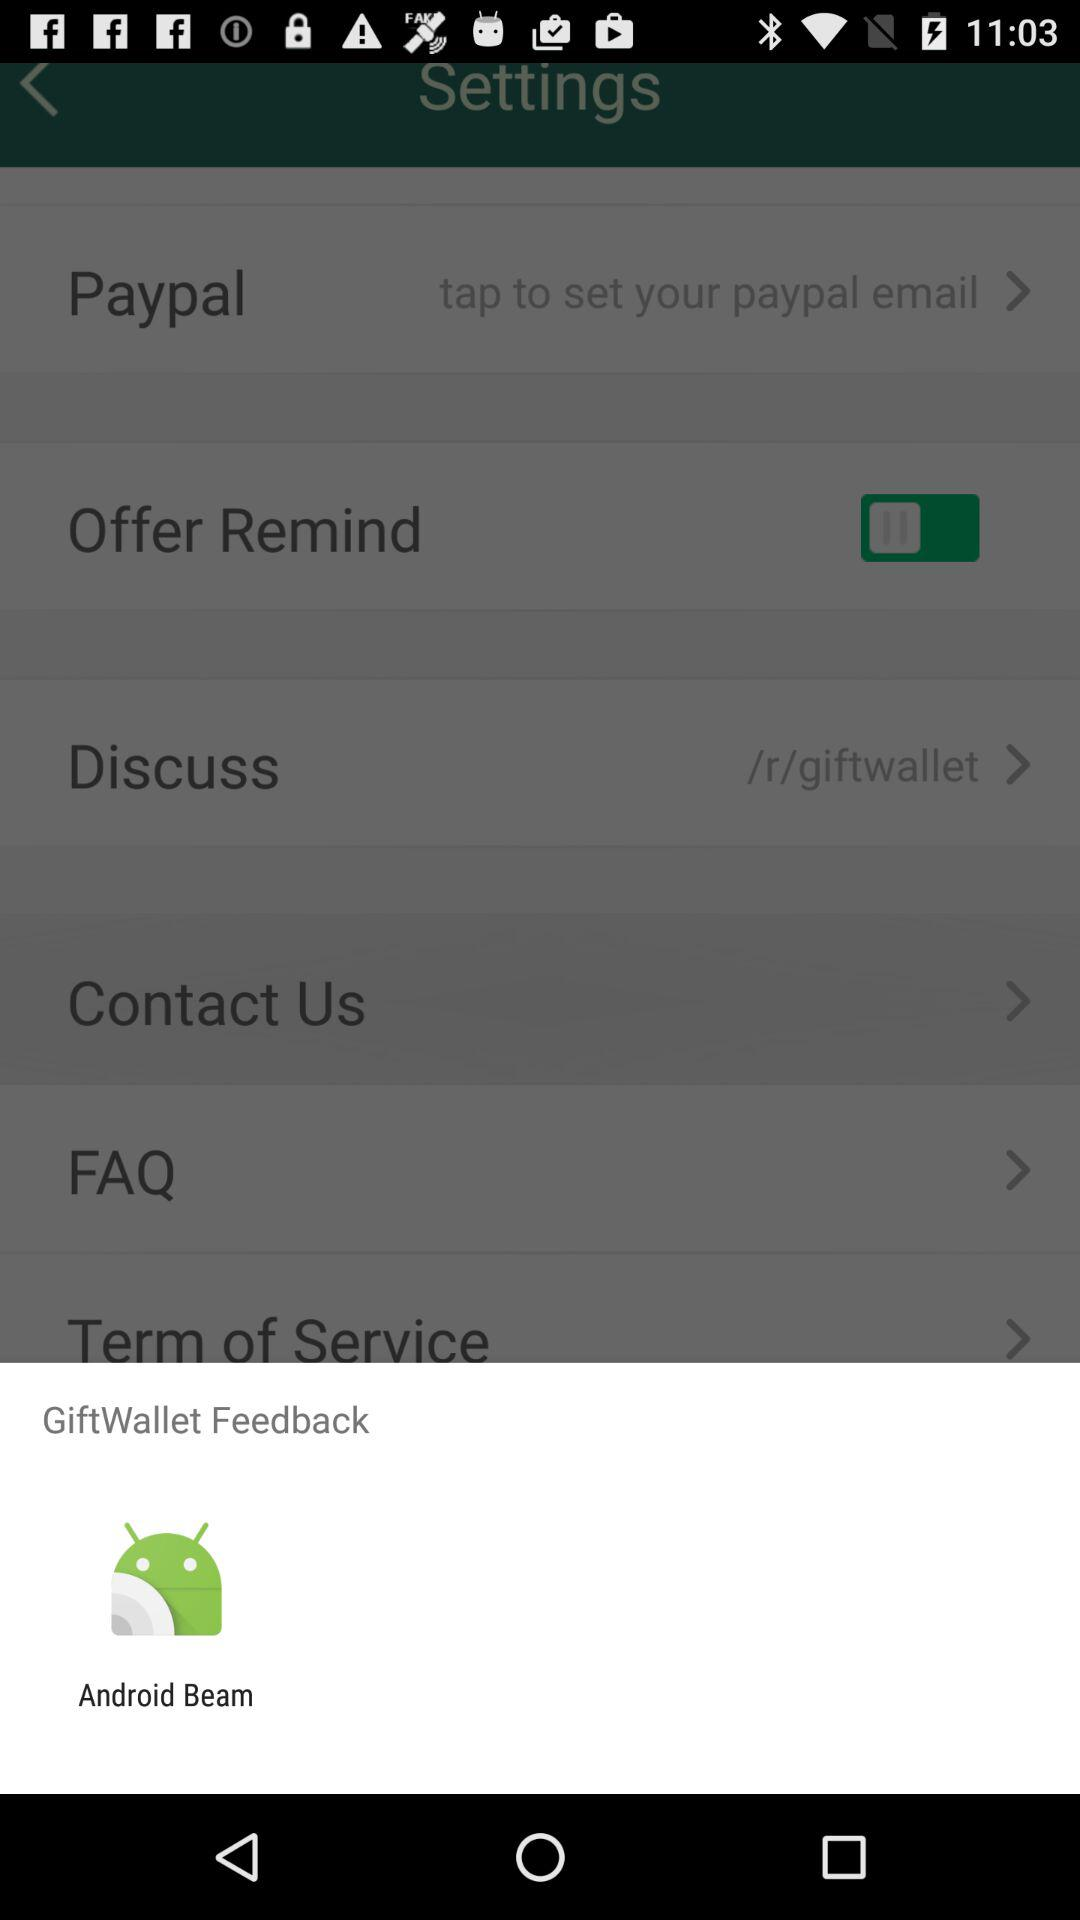What application can be used to open "GiftWallet" feedback? The application that can be used to open "GiftWallet" feedback is "Android Beam". 